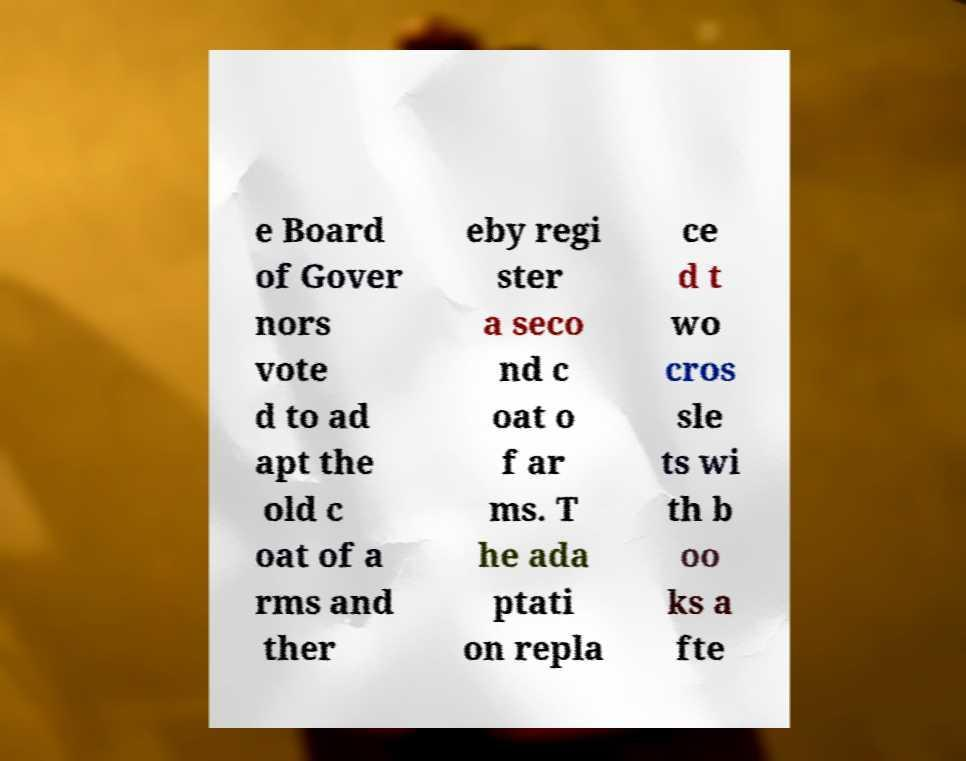There's text embedded in this image that I need extracted. Can you transcribe it verbatim? e Board of Gover nors vote d to ad apt the old c oat of a rms and ther eby regi ster a seco nd c oat o f ar ms. T he ada ptati on repla ce d t wo cros sle ts wi th b oo ks a fte 